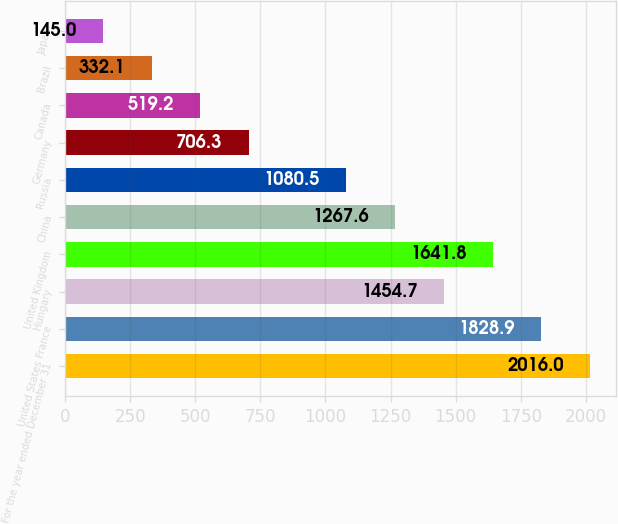<chart> <loc_0><loc_0><loc_500><loc_500><bar_chart><fcel>For the year ended December 31<fcel>United States France<fcel>Hungary<fcel>United Kingdom<fcel>China<fcel>Russia<fcel>Germany<fcel>Canada<fcel>Brazil<fcel>Japan<nl><fcel>2016<fcel>1828.9<fcel>1454.7<fcel>1641.8<fcel>1267.6<fcel>1080.5<fcel>706.3<fcel>519.2<fcel>332.1<fcel>145<nl></chart> 